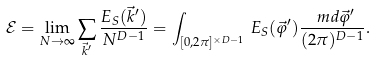Convert formula to latex. <formula><loc_0><loc_0><loc_500><loc_500>\mathcal { E } = \lim _ { N \rightarrow \infty } \sum _ { \vec { k } ^ { \prime } } \frac { E _ { S } ( \vec { k } ^ { \prime } ) } { N ^ { D - 1 } } = \int _ { [ 0 , 2 \pi ] ^ { \times D - 1 } } \, E _ { S } ( \vec { \varphi } ^ { \prime } ) \frac { \ m d \vec { \varphi } ^ { \prime } } { ( 2 \pi ) ^ { D - 1 } } .</formula> 